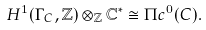Convert formula to latex. <formula><loc_0><loc_0><loc_500><loc_500>H ^ { 1 } ( \Gamma _ { C } , \mathbb { Z } ) \otimes _ { \mathbb { Z } } \mathbb { C } ^ { \ast } \cong \Pi c ^ { 0 } ( C ) .</formula> 